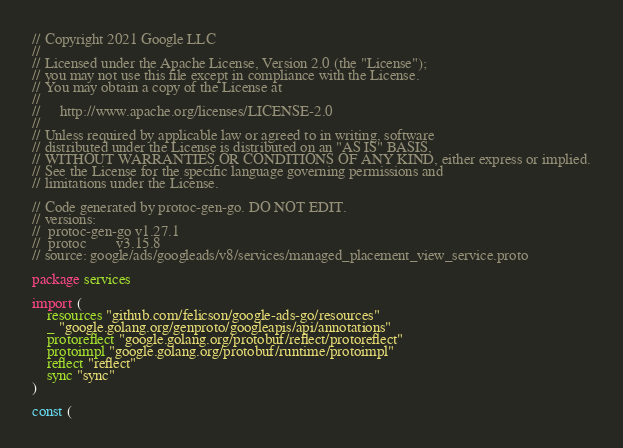<code> <loc_0><loc_0><loc_500><loc_500><_Go_>// Copyright 2021 Google LLC
//
// Licensed under the Apache License, Version 2.0 (the "License");
// you may not use this file except in compliance with the License.
// You may obtain a copy of the License at
//
//     http://www.apache.org/licenses/LICENSE-2.0
//
// Unless required by applicable law or agreed to in writing, software
// distributed under the License is distributed on an "AS IS" BASIS,
// WITHOUT WARRANTIES OR CONDITIONS OF ANY KIND, either express or implied.
// See the License for the specific language governing permissions and
// limitations under the License.

// Code generated by protoc-gen-go. DO NOT EDIT.
// versions:
// 	protoc-gen-go v1.27.1
// 	protoc        v3.15.8
// source: google/ads/googleads/v8/services/managed_placement_view_service.proto

package services

import (
	resources "github.com/felicson/google-ads-go/resources"
	_ "google.golang.org/genproto/googleapis/api/annotations"
	protoreflect "google.golang.org/protobuf/reflect/protoreflect"
	protoimpl "google.golang.org/protobuf/runtime/protoimpl"
	reflect "reflect"
	sync "sync"
)

const (</code> 